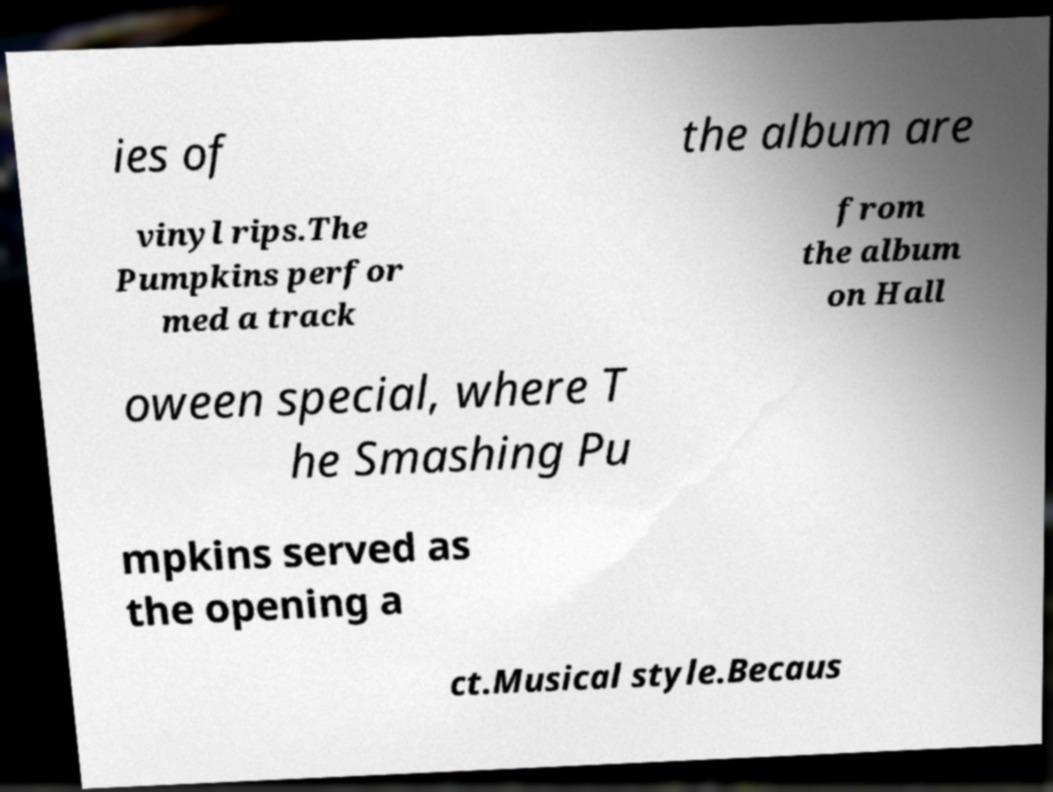There's text embedded in this image that I need extracted. Can you transcribe it verbatim? ies of the album are vinyl rips.The Pumpkins perfor med a track from the album on Hall oween special, where T he Smashing Pu mpkins served as the opening a ct.Musical style.Becaus 